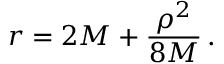<formula> <loc_0><loc_0><loc_500><loc_500>r = 2 M + { \frac { \rho ^ { 2 } } { 8 M } } \, .</formula> 